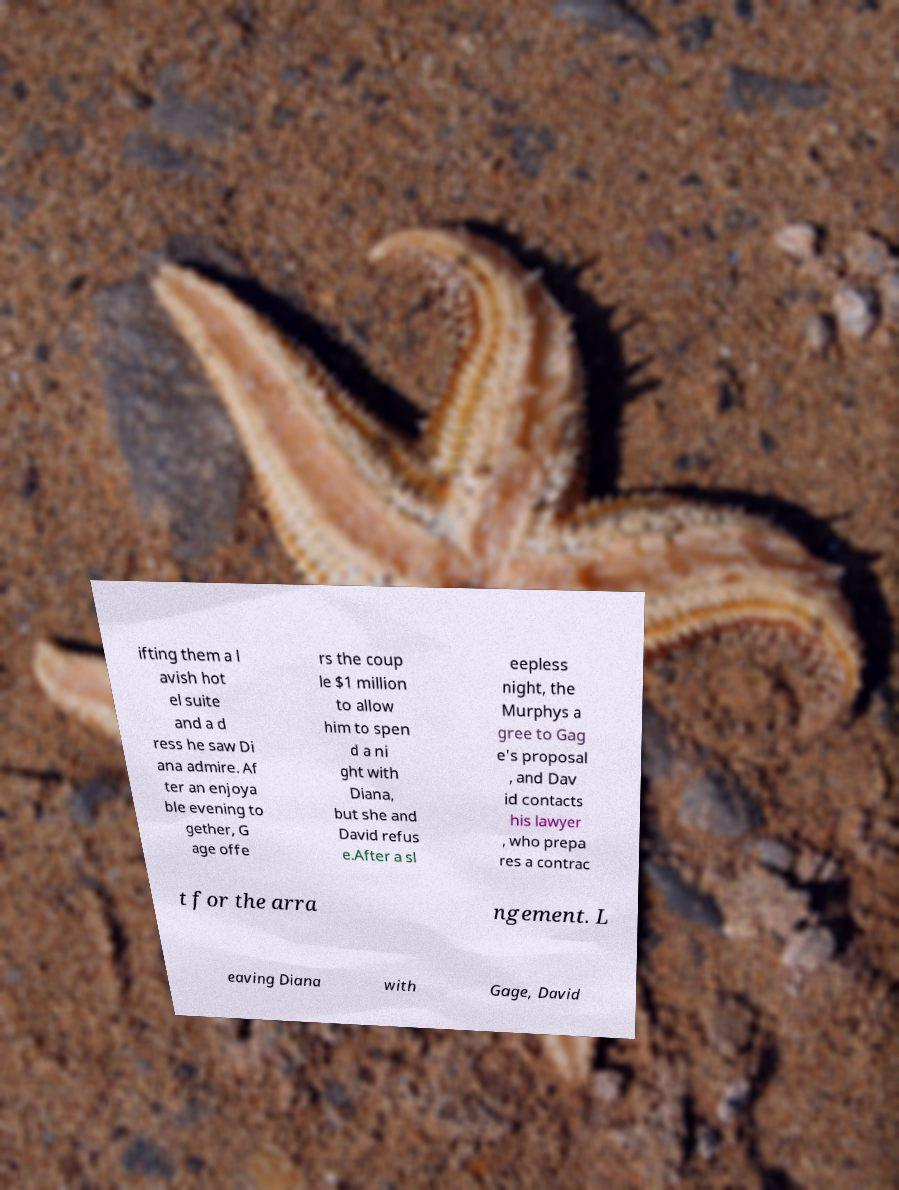Please read and relay the text visible in this image. What does it say? ifting them a l avish hot el suite and a d ress he saw Di ana admire. Af ter an enjoya ble evening to gether, G age offe rs the coup le $1 million to allow him to spen d a ni ght with Diana, but she and David refus e.After a sl eepless night, the Murphys a gree to Gag e's proposal , and Dav id contacts his lawyer , who prepa res a contrac t for the arra ngement. L eaving Diana with Gage, David 